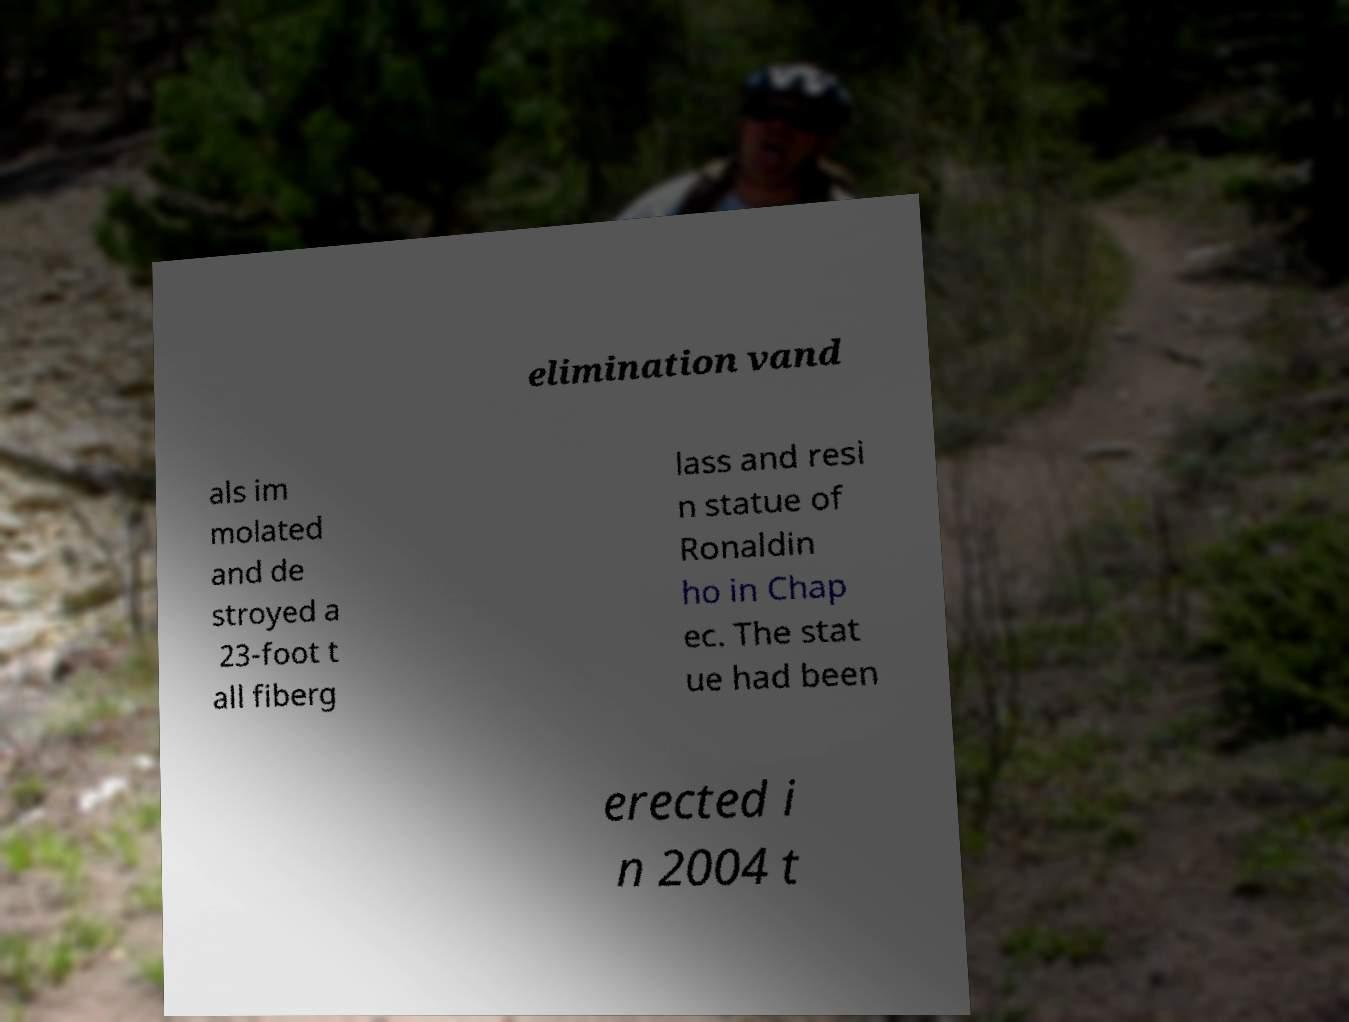Please read and relay the text visible in this image. What does it say? elimination vand als im molated and de stroyed a 23-foot t all fiberg lass and resi n statue of Ronaldin ho in Chap ec. The stat ue had been erected i n 2004 t 